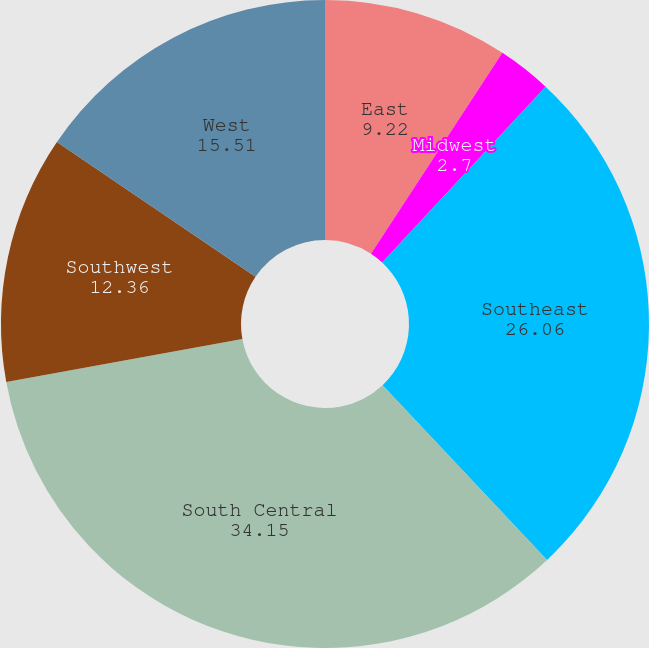Convert chart. <chart><loc_0><loc_0><loc_500><loc_500><pie_chart><fcel>East<fcel>Midwest<fcel>Southeast<fcel>South Central<fcel>Southwest<fcel>West<nl><fcel>9.22%<fcel>2.7%<fcel>26.06%<fcel>34.15%<fcel>12.36%<fcel>15.51%<nl></chart> 